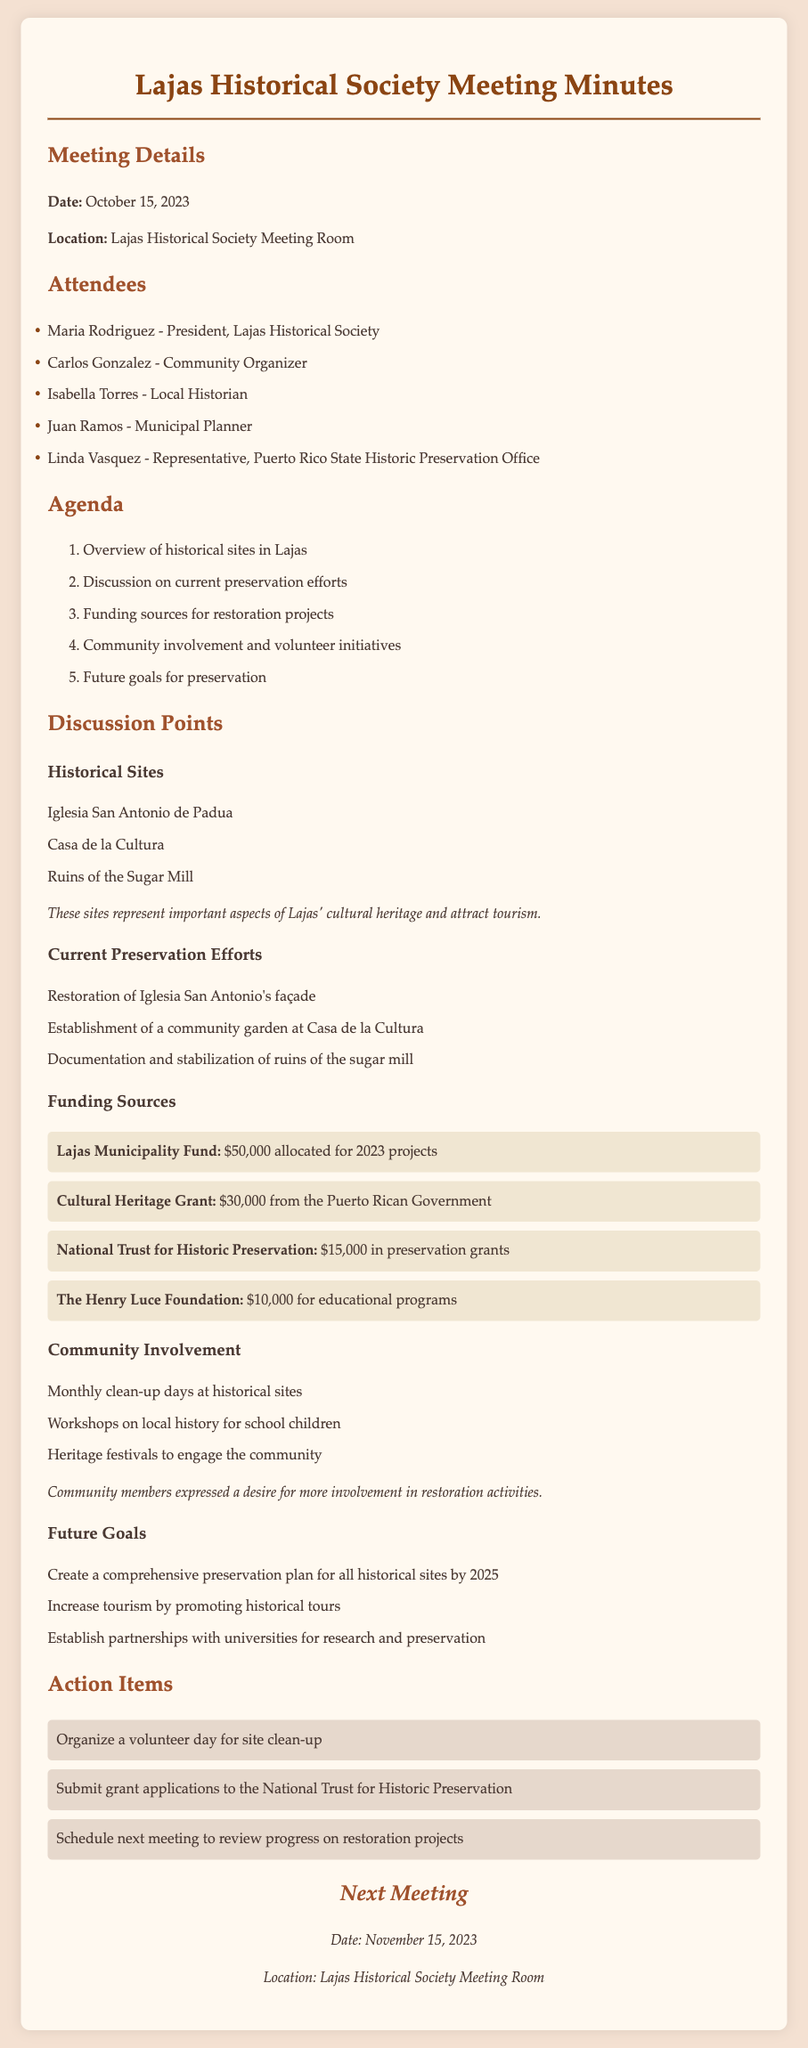What is the date of the next meeting? The next meeting date is explicitly listed in the document.
Answer: November 15, 2023 Who is the president of the Lajas Historical Society? The document lists Maria Rodriguez as the president, which is stated under attendees.
Answer: Maria Rodriguez What amount has been allocated from the Lajas Municipality Fund? This information is specifically mentioned under funding sources and can be directly retrieved.
Answer: $50,000 What is one of the current restoration efforts mentioned? Several current efforts are listed, and one of them is restoration of the church's façade.
Answer: Restoration of Iglesia San Antonio's façade What type of community involvement activity is mentioned? The document lists several involvement activities and one example is described in the community involvement section.
Answer: Monthly clean-up days at historical sites What total amount has been reported from the Cultural Heritage Grant? The specific funding amount is stated in the document under funding sources, which can be directly referenced.
Answer: $30,000 What is the goal for 2025 regarding historical site preservation? The future goals include a specific target for 2025, which is outlined in the future goals section.
Answer: Create a comprehensive preservation plan for all historical sites Which organization will receive grant applications according to the action items? The action item specifically mentions which organization will receive grant applications for the next steps.
Answer: National Trust for Historic Preservation 